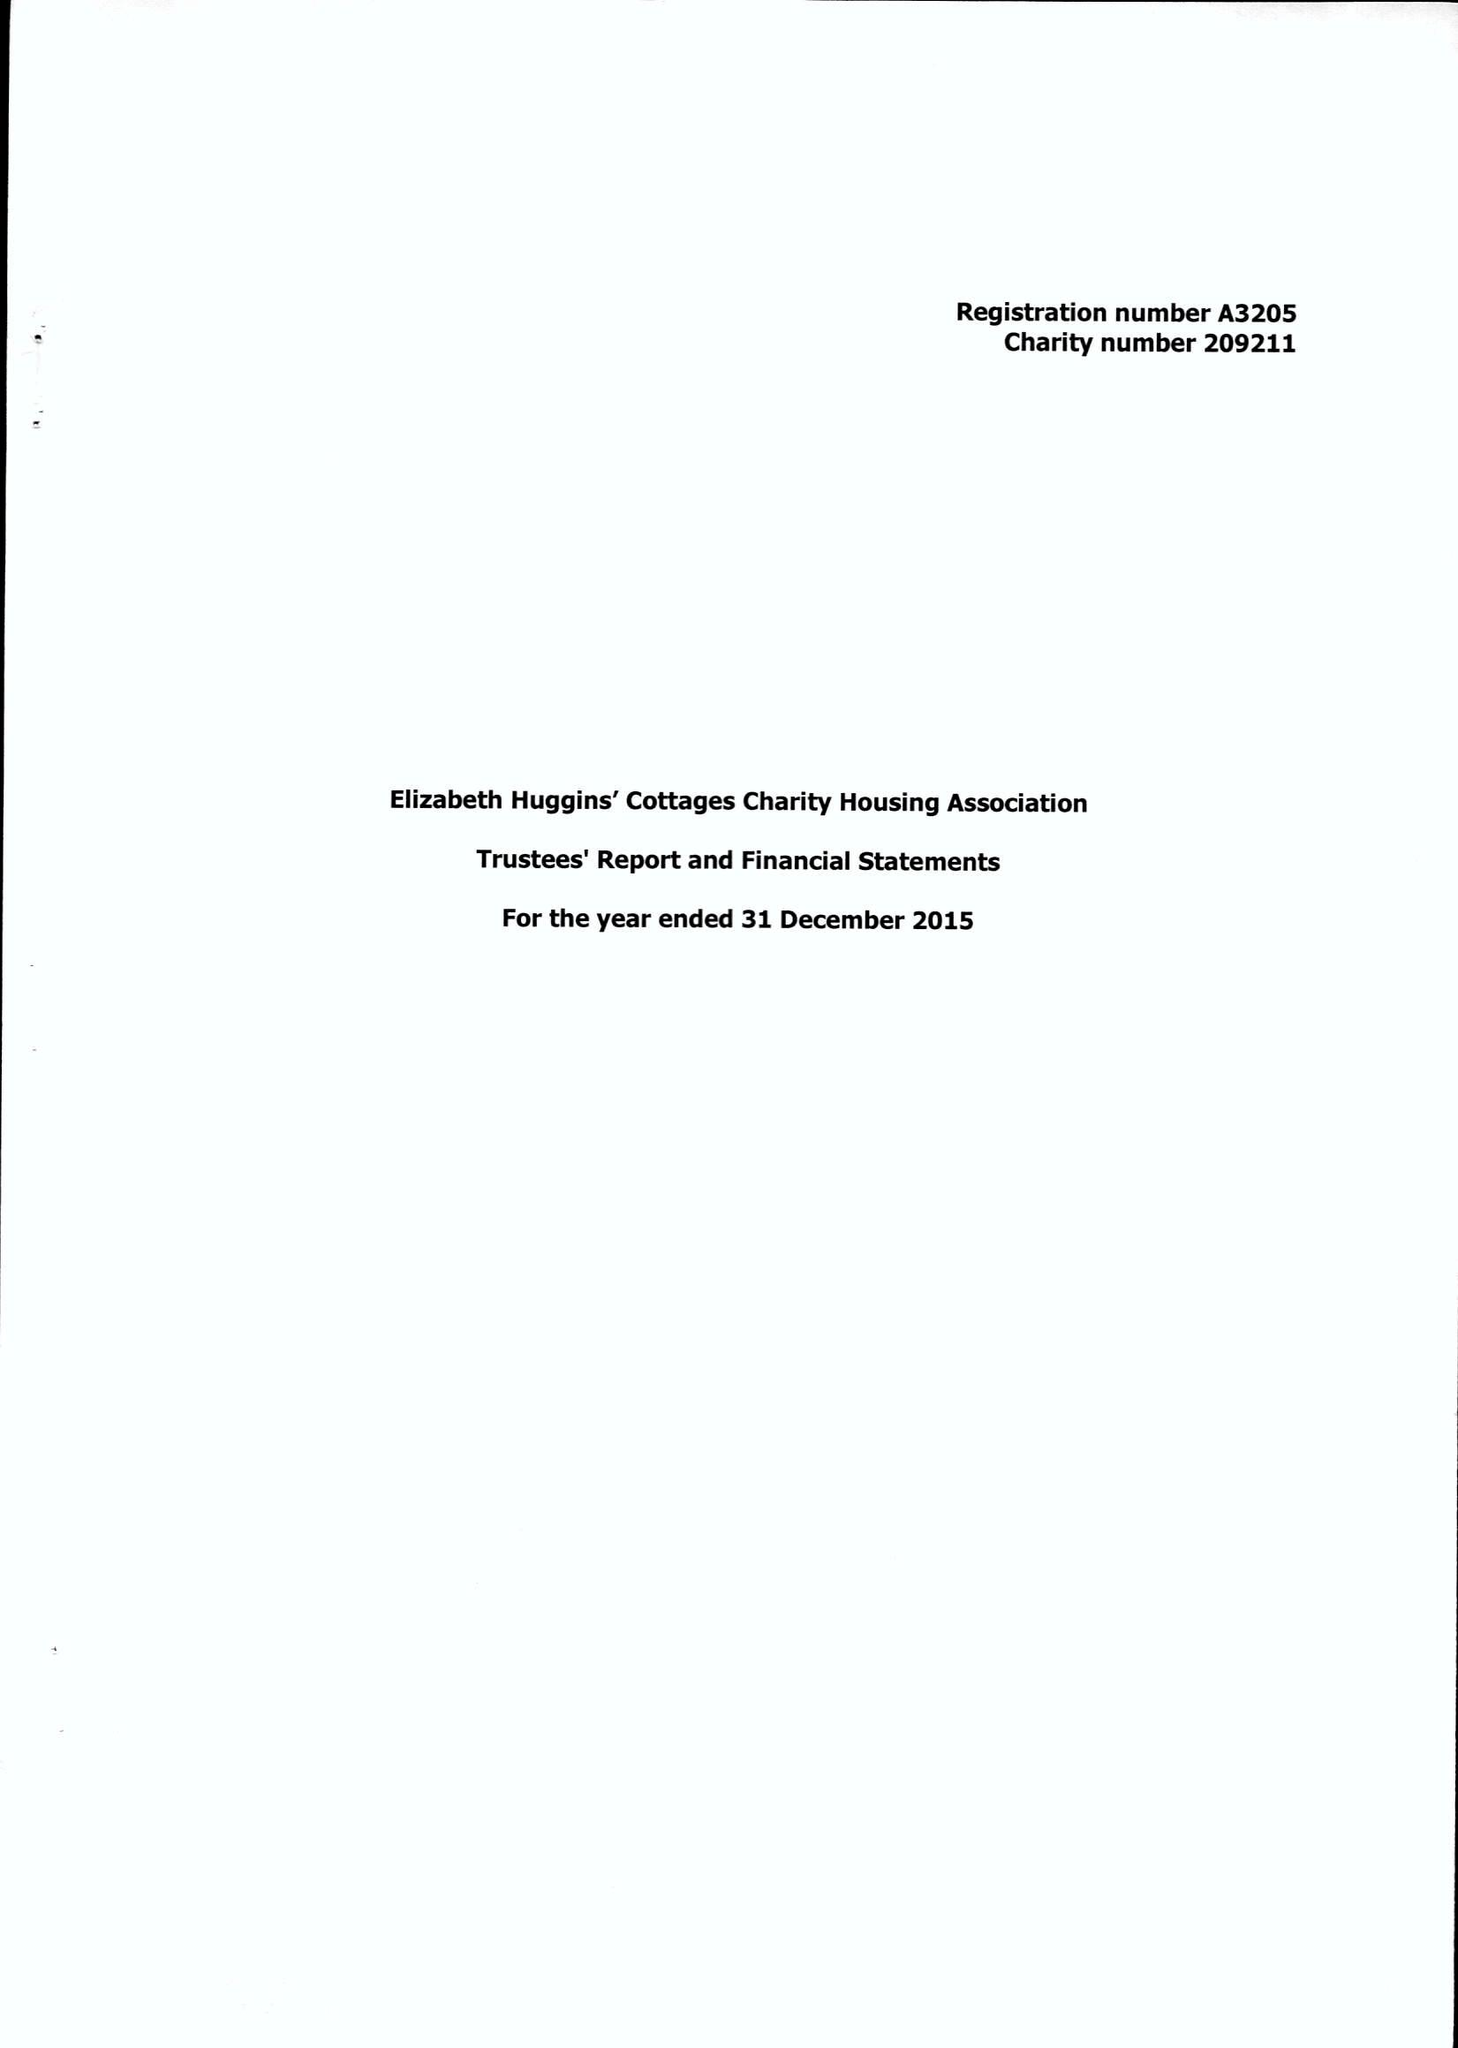What is the value for the spending_annually_in_british_pounds?
Answer the question using a single word or phrase. 59995.00 